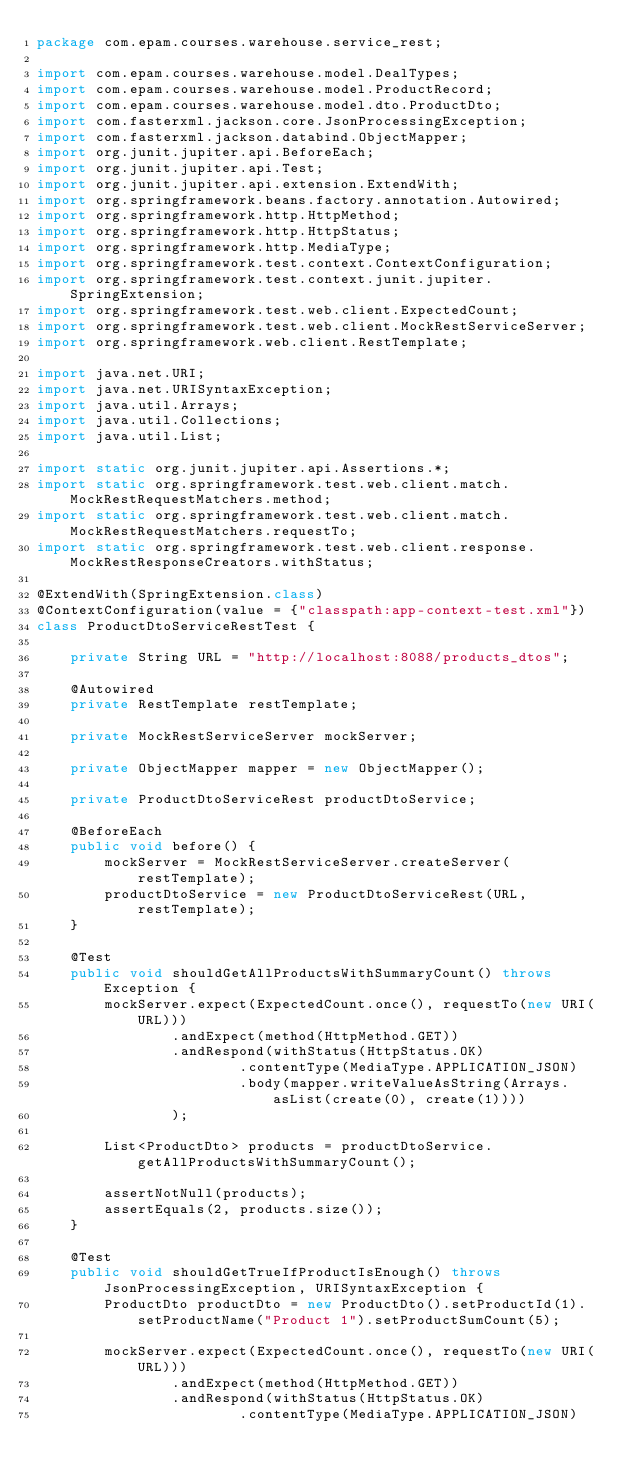<code> <loc_0><loc_0><loc_500><loc_500><_Java_>package com.epam.courses.warehouse.service_rest;

import com.epam.courses.warehouse.model.DealTypes;
import com.epam.courses.warehouse.model.ProductRecord;
import com.epam.courses.warehouse.model.dto.ProductDto;
import com.fasterxml.jackson.core.JsonProcessingException;
import com.fasterxml.jackson.databind.ObjectMapper;
import org.junit.jupiter.api.BeforeEach;
import org.junit.jupiter.api.Test;
import org.junit.jupiter.api.extension.ExtendWith;
import org.springframework.beans.factory.annotation.Autowired;
import org.springframework.http.HttpMethod;
import org.springframework.http.HttpStatus;
import org.springframework.http.MediaType;
import org.springframework.test.context.ContextConfiguration;
import org.springframework.test.context.junit.jupiter.SpringExtension;
import org.springframework.test.web.client.ExpectedCount;
import org.springframework.test.web.client.MockRestServiceServer;
import org.springframework.web.client.RestTemplate;

import java.net.URI;
import java.net.URISyntaxException;
import java.util.Arrays;
import java.util.Collections;
import java.util.List;

import static org.junit.jupiter.api.Assertions.*;
import static org.springframework.test.web.client.match.MockRestRequestMatchers.method;
import static org.springframework.test.web.client.match.MockRestRequestMatchers.requestTo;
import static org.springframework.test.web.client.response.MockRestResponseCreators.withStatus;

@ExtendWith(SpringExtension.class)
@ContextConfiguration(value = {"classpath:app-context-test.xml"})
class ProductDtoServiceRestTest {

    private String URL = "http://localhost:8088/products_dtos";

    @Autowired
    private RestTemplate restTemplate;

    private MockRestServiceServer mockServer;

    private ObjectMapper mapper = new ObjectMapper();

    private ProductDtoServiceRest productDtoService;

    @BeforeEach
    public void before() {
        mockServer = MockRestServiceServer.createServer(restTemplate);
        productDtoService = new ProductDtoServiceRest(URL, restTemplate);
    }

    @Test
    public void shouldGetAllProductsWithSummaryCount() throws Exception {
        mockServer.expect(ExpectedCount.once(), requestTo(new URI(URL)))
                .andExpect(method(HttpMethod.GET))
                .andRespond(withStatus(HttpStatus.OK)
                        .contentType(MediaType.APPLICATION_JSON)
                        .body(mapper.writeValueAsString(Arrays.asList(create(0), create(1))))
                );

        List<ProductDto> products = productDtoService.getAllProductsWithSummaryCount();

        assertNotNull(products);
        assertEquals(2, products.size());
    }

    @Test
    public void shouldGetTrueIfProductIsEnough() throws JsonProcessingException, URISyntaxException {
        ProductDto productDto = new ProductDto().setProductId(1).setProductName("Product 1").setProductSumCount(5);

        mockServer.expect(ExpectedCount.once(), requestTo(new URI(URL)))
                .andExpect(method(HttpMethod.GET))
                .andRespond(withStatus(HttpStatus.OK)
                        .contentType(MediaType.APPLICATION_JSON)</code> 